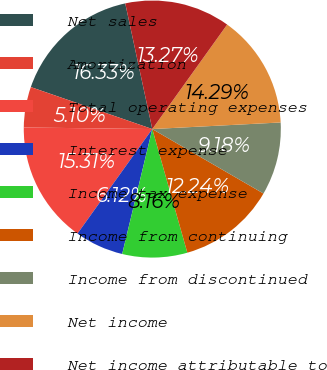Convert chart. <chart><loc_0><loc_0><loc_500><loc_500><pie_chart><fcel>Net sales<fcel>Amortization<fcel>Total operating expenses<fcel>Interest expense<fcel>Income tax expense<fcel>Income from continuing<fcel>Income from discontinued<fcel>Net income<fcel>Net income attributable to<nl><fcel>16.33%<fcel>5.1%<fcel>15.31%<fcel>6.12%<fcel>8.16%<fcel>12.24%<fcel>9.18%<fcel>14.29%<fcel>13.27%<nl></chart> 